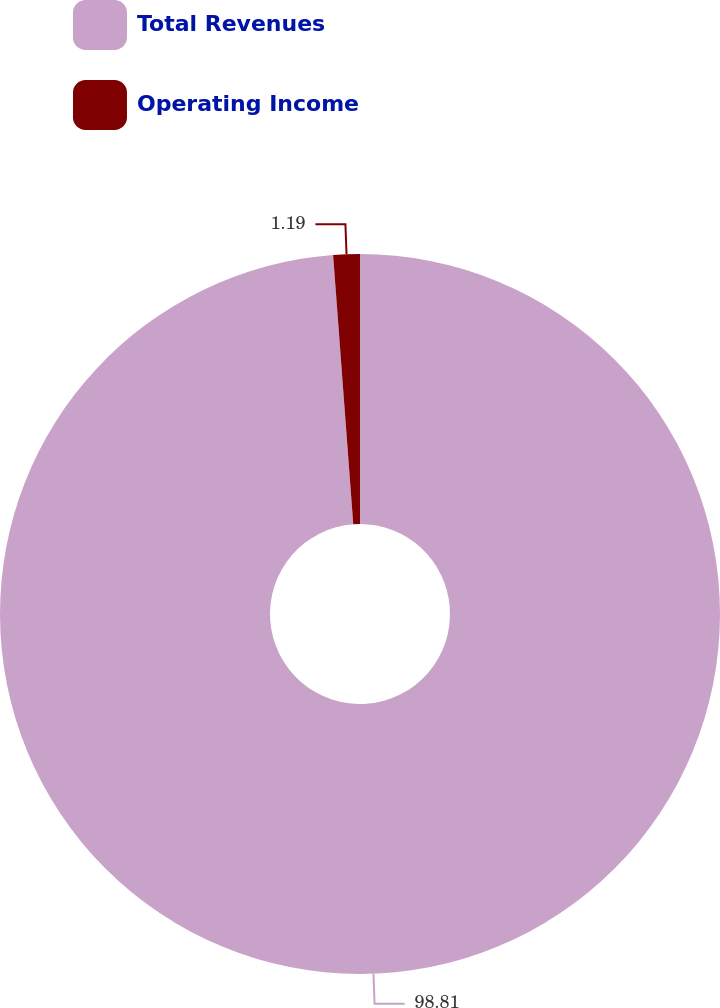Convert chart to OTSL. <chart><loc_0><loc_0><loc_500><loc_500><pie_chart><fcel>Total Revenues<fcel>Operating Income<nl><fcel>98.81%<fcel>1.19%<nl></chart> 